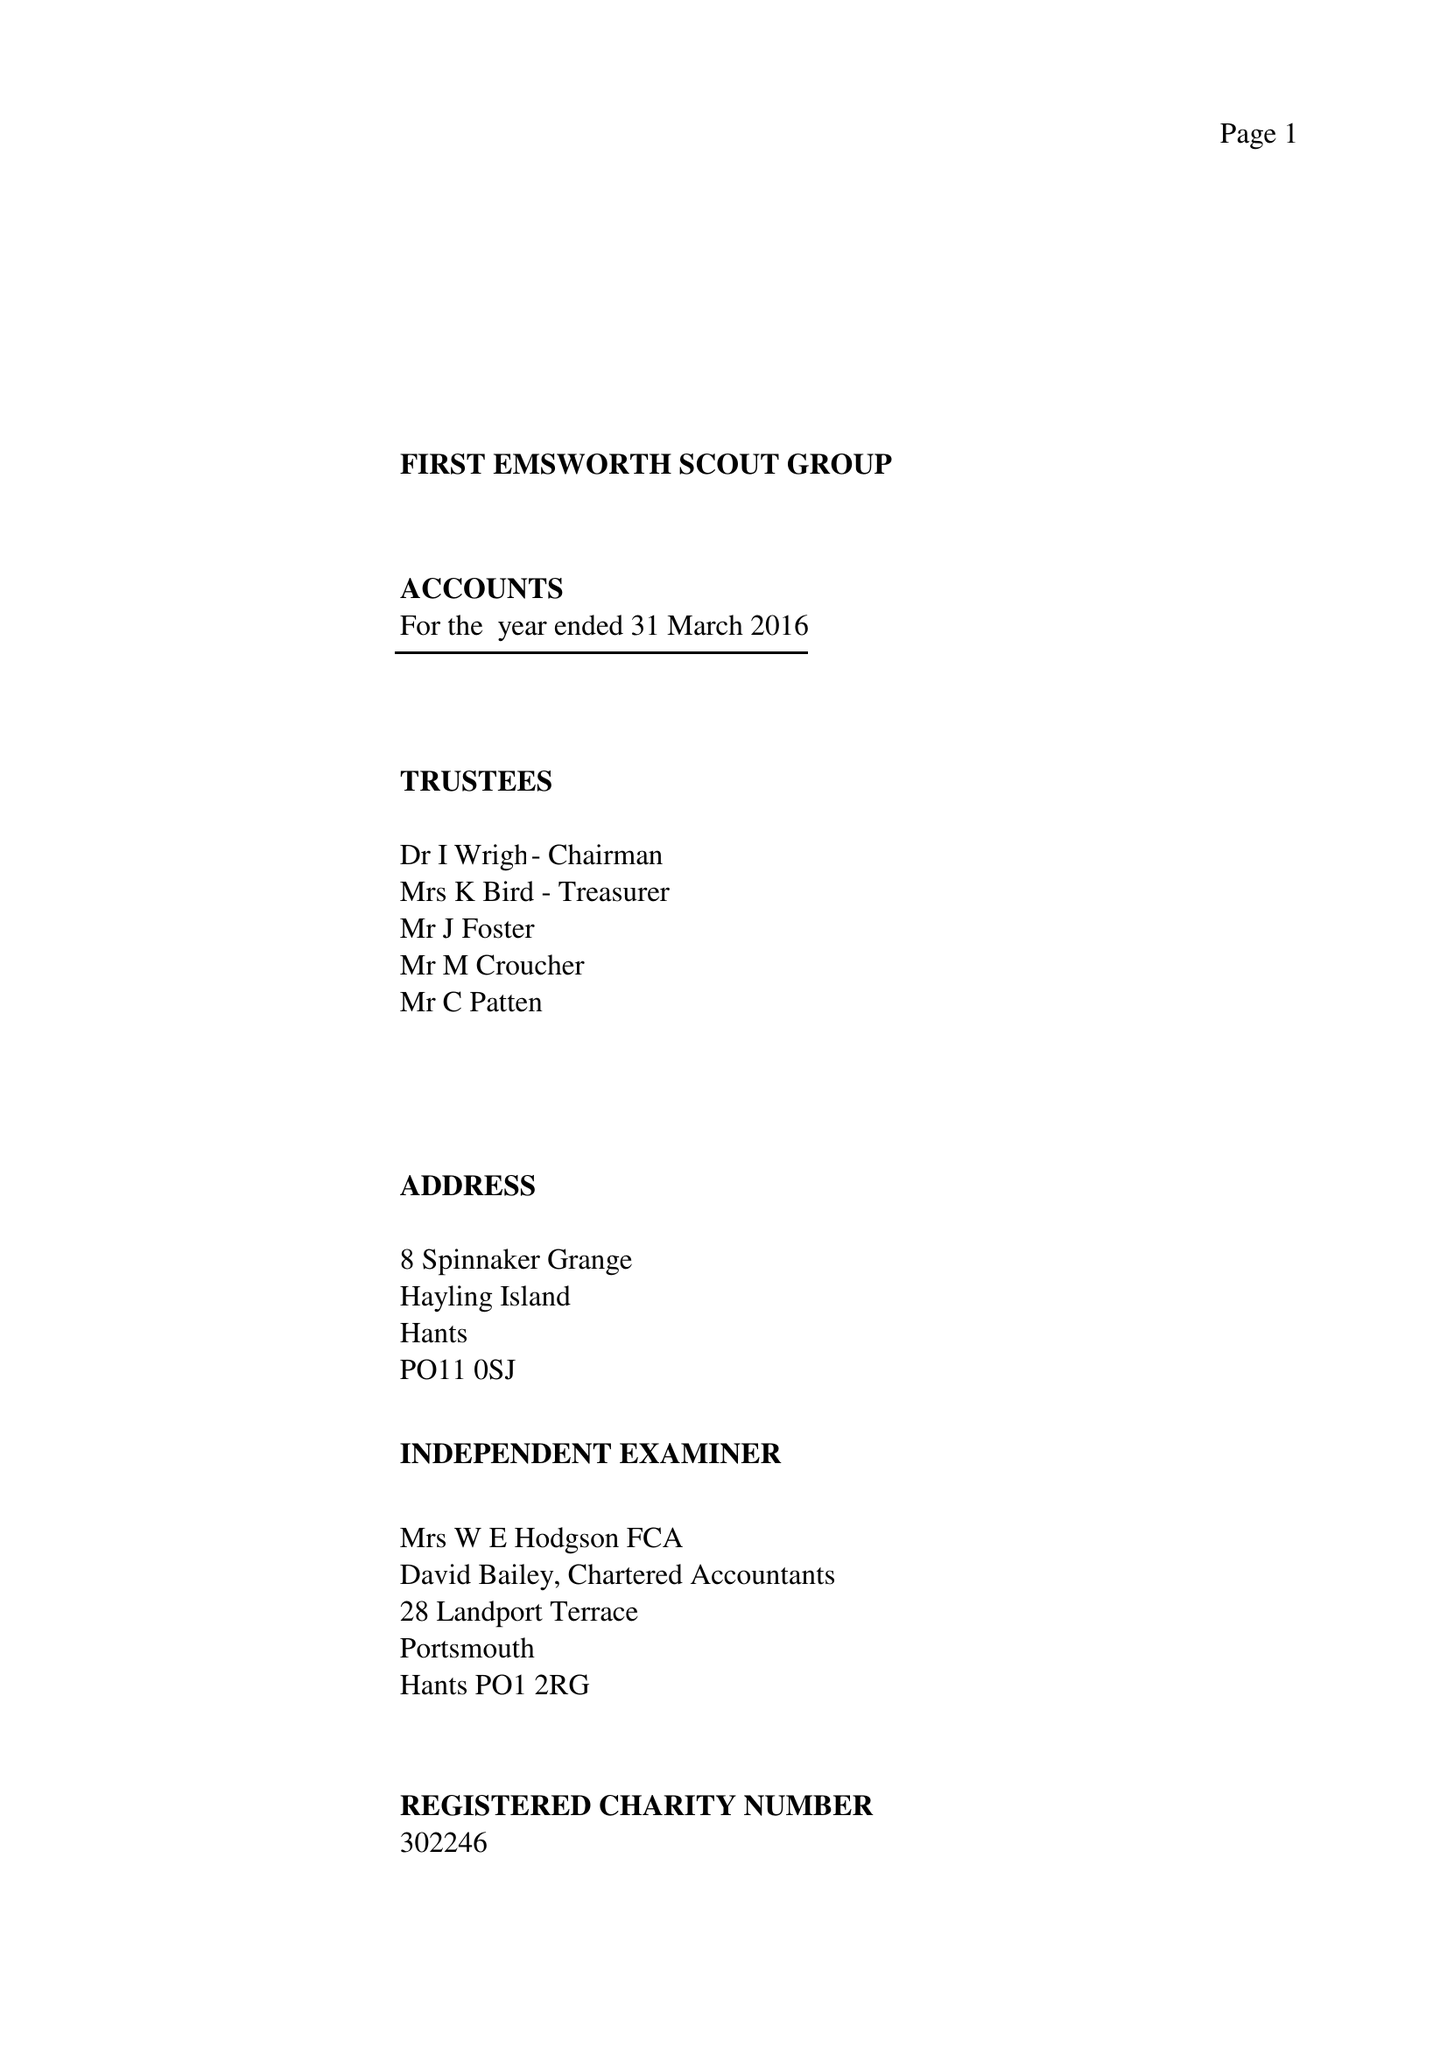What is the value for the address__street_line?
Answer the question using a single word or phrase. 8 SPINNAKER GRANGE 